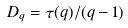Convert formula to latex. <formula><loc_0><loc_0><loc_500><loc_500>D _ { q } = \tau ( q ) / ( q - 1 )</formula> 